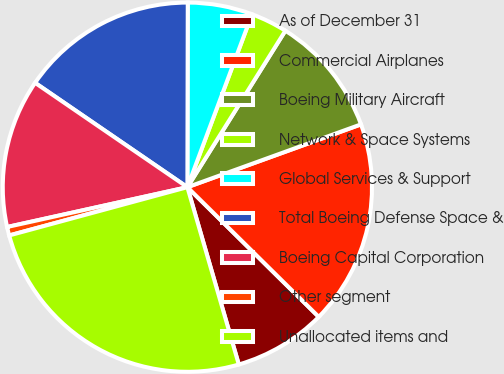Convert chart to OTSL. <chart><loc_0><loc_0><loc_500><loc_500><pie_chart><fcel>As of December 31<fcel>Commercial Airplanes<fcel>Boeing Military Aircraft<fcel>Network & Space Systems<fcel>Global Services & Support<fcel>Total Boeing Defense Space &<fcel>Boeing Capital Corporation<fcel>Other segment<fcel>Unallocated items and<nl><fcel>8.11%<fcel>17.92%<fcel>10.57%<fcel>3.21%<fcel>5.66%<fcel>15.47%<fcel>13.02%<fcel>0.75%<fcel>25.28%<nl></chart> 